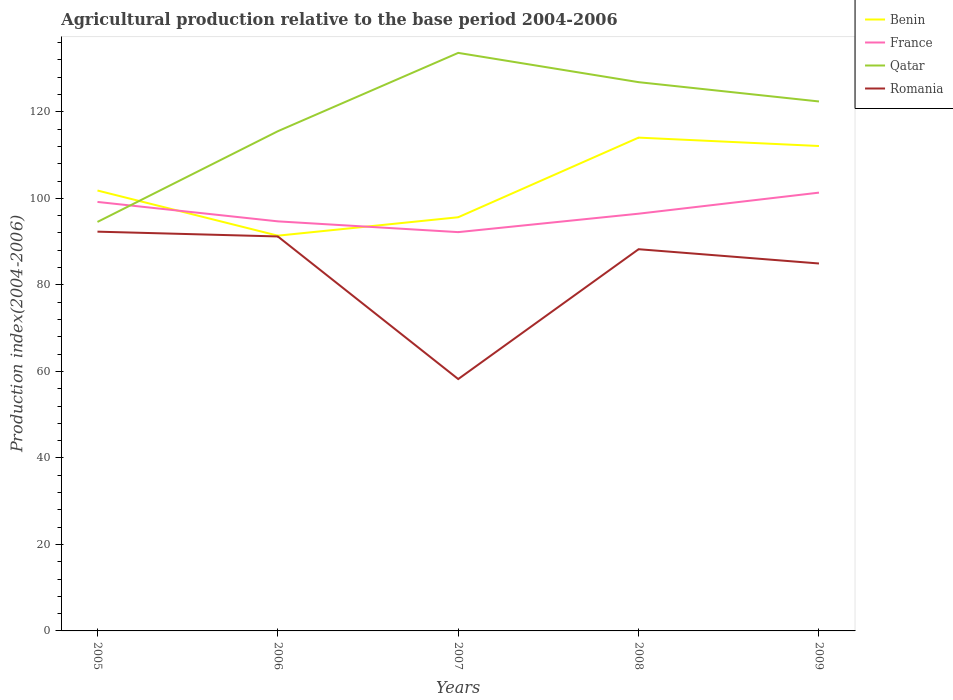Does the line corresponding to Qatar intersect with the line corresponding to Romania?
Give a very brief answer. No. Across all years, what is the maximum agricultural production index in Qatar?
Your response must be concise. 94.56. In which year was the agricultural production index in Qatar maximum?
Provide a succinct answer. 2005. What is the total agricultural production index in Romania in the graph?
Ensure brevity in your answer.  7.36. What is the difference between the highest and the second highest agricultural production index in Benin?
Provide a succinct answer. 22.67. What is the difference between the highest and the lowest agricultural production index in Qatar?
Ensure brevity in your answer.  3. Is the agricultural production index in France strictly greater than the agricultural production index in Romania over the years?
Ensure brevity in your answer.  No. How many lines are there?
Your answer should be very brief. 4. How many years are there in the graph?
Make the answer very short. 5. Are the values on the major ticks of Y-axis written in scientific E-notation?
Your response must be concise. No. Does the graph contain grids?
Ensure brevity in your answer.  No. How are the legend labels stacked?
Ensure brevity in your answer.  Vertical. What is the title of the graph?
Provide a short and direct response. Agricultural production relative to the base period 2004-2006. Does "United Kingdom" appear as one of the legend labels in the graph?
Provide a short and direct response. No. What is the label or title of the Y-axis?
Ensure brevity in your answer.  Production index(2004-2006). What is the Production index(2004-2006) in Benin in 2005?
Offer a very short reply. 101.82. What is the Production index(2004-2006) in France in 2005?
Offer a terse response. 99.18. What is the Production index(2004-2006) in Qatar in 2005?
Your answer should be compact. 94.56. What is the Production index(2004-2006) of Romania in 2005?
Offer a very short reply. 92.31. What is the Production index(2004-2006) of Benin in 2006?
Make the answer very short. 91.38. What is the Production index(2004-2006) of France in 2006?
Make the answer very short. 94.69. What is the Production index(2004-2006) in Qatar in 2006?
Provide a succinct answer. 115.53. What is the Production index(2004-2006) in Romania in 2006?
Your response must be concise. 91.2. What is the Production index(2004-2006) in Benin in 2007?
Keep it short and to the point. 95.64. What is the Production index(2004-2006) in France in 2007?
Offer a terse response. 92.2. What is the Production index(2004-2006) in Qatar in 2007?
Make the answer very short. 133.64. What is the Production index(2004-2006) in Romania in 2007?
Give a very brief answer. 58.23. What is the Production index(2004-2006) of Benin in 2008?
Keep it short and to the point. 114.05. What is the Production index(2004-2006) of France in 2008?
Keep it short and to the point. 96.46. What is the Production index(2004-2006) in Qatar in 2008?
Your response must be concise. 126.87. What is the Production index(2004-2006) of Romania in 2008?
Your answer should be compact. 88.25. What is the Production index(2004-2006) in Benin in 2009?
Make the answer very short. 112.11. What is the Production index(2004-2006) of France in 2009?
Offer a very short reply. 101.33. What is the Production index(2004-2006) of Qatar in 2009?
Your response must be concise. 122.41. What is the Production index(2004-2006) in Romania in 2009?
Your answer should be very brief. 84.95. Across all years, what is the maximum Production index(2004-2006) of Benin?
Make the answer very short. 114.05. Across all years, what is the maximum Production index(2004-2006) in France?
Your answer should be compact. 101.33. Across all years, what is the maximum Production index(2004-2006) in Qatar?
Give a very brief answer. 133.64. Across all years, what is the maximum Production index(2004-2006) in Romania?
Provide a succinct answer. 92.31. Across all years, what is the minimum Production index(2004-2006) in Benin?
Keep it short and to the point. 91.38. Across all years, what is the minimum Production index(2004-2006) of France?
Your answer should be very brief. 92.2. Across all years, what is the minimum Production index(2004-2006) of Qatar?
Keep it short and to the point. 94.56. Across all years, what is the minimum Production index(2004-2006) in Romania?
Provide a succinct answer. 58.23. What is the total Production index(2004-2006) of Benin in the graph?
Ensure brevity in your answer.  515. What is the total Production index(2004-2006) of France in the graph?
Your answer should be very brief. 483.86. What is the total Production index(2004-2006) in Qatar in the graph?
Provide a succinct answer. 593.01. What is the total Production index(2004-2006) in Romania in the graph?
Your answer should be compact. 414.94. What is the difference between the Production index(2004-2006) in Benin in 2005 and that in 2006?
Make the answer very short. 10.44. What is the difference between the Production index(2004-2006) in France in 2005 and that in 2006?
Your answer should be very brief. 4.49. What is the difference between the Production index(2004-2006) in Qatar in 2005 and that in 2006?
Provide a succinct answer. -20.97. What is the difference between the Production index(2004-2006) in Romania in 2005 and that in 2006?
Provide a short and direct response. 1.11. What is the difference between the Production index(2004-2006) in Benin in 2005 and that in 2007?
Ensure brevity in your answer.  6.18. What is the difference between the Production index(2004-2006) of France in 2005 and that in 2007?
Make the answer very short. 6.98. What is the difference between the Production index(2004-2006) of Qatar in 2005 and that in 2007?
Give a very brief answer. -39.08. What is the difference between the Production index(2004-2006) in Romania in 2005 and that in 2007?
Make the answer very short. 34.08. What is the difference between the Production index(2004-2006) of Benin in 2005 and that in 2008?
Offer a very short reply. -12.23. What is the difference between the Production index(2004-2006) of France in 2005 and that in 2008?
Keep it short and to the point. 2.72. What is the difference between the Production index(2004-2006) of Qatar in 2005 and that in 2008?
Ensure brevity in your answer.  -32.31. What is the difference between the Production index(2004-2006) in Romania in 2005 and that in 2008?
Provide a succinct answer. 4.06. What is the difference between the Production index(2004-2006) of Benin in 2005 and that in 2009?
Offer a very short reply. -10.29. What is the difference between the Production index(2004-2006) of France in 2005 and that in 2009?
Provide a short and direct response. -2.15. What is the difference between the Production index(2004-2006) of Qatar in 2005 and that in 2009?
Provide a succinct answer. -27.85. What is the difference between the Production index(2004-2006) of Romania in 2005 and that in 2009?
Provide a short and direct response. 7.36. What is the difference between the Production index(2004-2006) of Benin in 2006 and that in 2007?
Keep it short and to the point. -4.26. What is the difference between the Production index(2004-2006) of France in 2006 and that in 2007?
Make the answer very short. 2.49. What is the difference between the Production index(2004-2006) in Qatar in 2006 and that in 2007?
Provide a short and direct response. -18.11. What is the difference between the Production index(2004-2006) of Romania in 2006 and that in 2007?
Provide a succinct answer. 32.97. What is the difference between the Production index(2004-2006) of Benin in 2006 and that in 2008?
Your answer should be compact. -22.67. What is the difference between the Production index(2004-2006) in France in 2006 and that in 2008?
Provide a short and direct response. -1.77. What is the difference between the Production index(2004-2006) of Qatar in 2006 and that in 2008?
Give a very brief answer. -11.34. What is the difference between the Production index(2004-2006) of Romania in 2006 and that in 2008?
Your answer should be compact. 2.95. What is the difference between the Production index(2004-2006) of Benin in 2006 and that in 2009?
Ensure brevity in your answer.  -20.73. What is the difference between the Production index(2004-2006) in France in 2006 and that in 2009?
Offer a very short reply. -6.64. What is the difference between the Production index(2004-2006) of Qatar in 2006 and that in 2009?
Ensure brevity in your answer.  -6.88. What is the difference between the Production index(2004-2006) of Romania in 2006 and that in 2009?
Keep it short and to the point. 6.25. What is the difference between the Production index(2004-2006) of Benin in 2007 and that in 2008?
Give a very brief answer. -18.41. What is the difference between the Production index(2004-2006) of France in 2007 and that in 2008?
Offer a very short reply. -4.26. What is the difference between the Production index(2004-2006) of Qatar in 2007 and that in 2008?
Keep it short and to the point. 6.77. What is the difference between the Production index(2004-2006) in Romania in 2007 and that in 2008?
Your answer should be very brief. -30.02. What is the difference between the Production index(2004-2006) of Benin in 2007 and that in 2009?
Offer a terse response. -16.47. What is the difference between the Production index(2004-2006) of France in 2007 and that in 2009?
Offer a very short reply. -9.13. What is the difference between the Production index(2004-2006) of Qatar in 2007 and that in 2009?
Ensure brevity in your answer.  11.23. What is the difference between the Production index(2004-2006) in Romania in 2007 and that in 2009?
Ensure brevity in your answer.  -26.72. What is the difference between the Production index(2004-2006) of Benin in 2008 and that in 2009?
Your answer should be compact. 1.94. What is the difference between the Production index(2004-2006) of France in 2008 and that in 2009?
Your answer should be compact. -4.87. What is the difference between the Production index(2004-2006) of Qatar in 2008 and that in 2009?
Offer a terse response. 4.46. What is the difference between the Production index(2004-2006) of Benin in 2005 and the Production index(2004-2006) of France in 2006?
Your answer should be very brief. 7.13. What is the difference between the Production index(2004-2006) in Benin in 2005 and the Production index(2004-2006) in Qatar in 2006?
Give a very brief answer. -13.71. What is the difference between the Production index(2004-2006) in Benin in 2005 and the Production index(2004-2006) in Romania in 2006?
Give a very brief answer. 10.62. What is the difference between the Production index(2004-2006) in France in 2005 and the Production index(2004-2006) in Qatar in 2006?
Ensure brevity in your answer.  -16.35. What is the difference between the Production index(2004-2006) in France in 2005 and the Production index(2004-2006) in Romania in 2006?
Your answer should be very brief. 7.98. What is the difference between the Production index(2004-2006) of Qatar in 2005 and the Production index(2004-2006) of Romania in 2006?
Provide a succinct answer. 3.36. What is the difference between the Production index(2004-2006) of Benin in 2005 and the Production index(2004-2006) of France in 2007?
Make the answer very short. 9.62. What is the difference between the Production index(2004-2006) in Benin in 2005 and the Production index(2004-2006) in Qatar in 2007?
Your answer should be compact. -31.82. What is the difference between the Production index(2004-2006) of Benin in 2005 and the Production index(2004-2006) of Romania in 2007?
Give a very brief answer. 43.59. What is the difference between the Production index(2004-2006) of France in 2005 and the Production index(2004-2006) of Qatar in 2007?
Give a very brief answer. -34.46. What is the difference between the Production index(2004-2006) of France in 2005 and the Production index(2004-2006) of Romania in 2007?
Provide a short and direct response. 40.95. What is the difference between the Production index(2004-2006) in Qatar in 2005 and the Production index(2004-2006) in Romania in 2007?
Your response must be concise. 36.33. What is the difference between the Production index(2004-2006) of Benin in 2005 and the Production index(2004-2006) of France in 2008?
Give a very brief answer. 5.36. What is the difference between the Production index(2004-2006) of Benin in 2005 and the Production index(2004-2006) of Qatar in 2008?
Make the answer very short. -25.05. What is the difference between the Production index(2004-2006) in Benin in 2005 and the Production index(2004-2006) in Romania in 2008?
Make the answer very short. 13.57. What is the difference between the Production index(2004-2006) of France in 2005 and the Production index(2004-2006) of Qatar in 2008?
Give a very brief answer. -27.69. What is the difference between the Production index(2004-2006) of France in 2005 and the Production index(2004-2006) of Romania in 2008?
Keep it short and to the point. 10.93. What is the difference between the Production index(2004-2006) in Qatar in 2005 and the Production index(2004-2006) in Romania in 2008?
Provide a succinct answer. 6.31. What is the difference between the Production index(2004-2006) of Benin in 2005 and the Production index(2004-2006) of France in 2009?
Give a very brief answer. 0.49. What is the difference between the Production index(2004-2006) in Benin in 2005 and the Production index(2004-2006) in Qatar in 2009?
Keep it short and to the point. -20.59. What is the difference between the Production index(2004-2006) of Benin in 2005 and the Production index(2004-2006) of Romania in 2009?
Your answer should be very brief. 16.87. What is the difference between the Production index(2004-2006) of France in 2005 and the Production index(2004-2006) of Qatar in 2009?
Make the answer very short. -23.23. What is the difference between the Production index(2004-2006) in France in 2005 and the Production index(2004-2006) in Romania in 2009?
Your response must be concise. 14.23. What is the difference between the Production index(2004-2006) of Qatar in 2005 and the Production index(2004-2006) of Romania in 2009?
Provide a succinct answer. 9.61. What is the difference between the Production index(2004-2006) in Benin in 2006 and the Production index(2004-2006) in France in 2007?
Your answer should be very brief. -0.82. What is the difference between the Production index(2004-2006) of Benin in 2006 and the Production index(2004-2006) of Qatar in 2007?
Offer a terse response. -42.26. What is the difference between the Production index(2004-2006) in Benin in 2006 and the Production index(2004-2006) in Romania in 2007?
Ensure brevity in your answer.  33.15. What is the difference between the Production index(2004-2006) in France in 2006 and the Production index(2004-2006) in Qatar in 2007?
Offer a very short reply. -38.95. What is the difference between the Production index(2004-2006) of France in 2006 and the Production index(2004-2006) of Romania in 2007?
Provide a succinct answer. 36.46. What is the difference between the Production index(2004-2006) of Qatar in 2006 and the Production index(2004-2006) of Romania in 2007?
Ensure brevity in your answer.  57.3. What is the difference between the Production index(2004-2006) of Benin in 2006 and the Production index(2004-2006) of France in 2008?
Ensure brevity in your answer.  -5.08. What is the difference between the Production index(2004-2006) of Benin in 2006 and the Production index(2004-2006) of Qatar in 2008?
Give a very brief answer. -35.49. What is the difference between the Production index(2004-2006) in Benin in 2006 and the Production index(2004-2006) in Romania in 2008?
Make the answer very short. 3.13. What is the difference between the Production index(2004-2006) of France in 2006 and the Production index(2004-2006) of Qatar in 2008?
Make the answer very short. -32.18. What is the difference between the Production index(2004-2006) in France in 2006 and the Production index(2004-2006) in Romania in 2008?
Your answer should be very brief. 6.44. What is the difference between the Production index(2004-2006) in Qatar in 2006 and the Production index(2004-2006) in Romania in 2008?
Your answer should be very brief. 27.28. What is the difference between the Production index(2004-2006) in Benin in 2006 and the Production index(2004-2006) in France in 2009?
Offer a very short reply. -9.95. What is the difference between the Production index(2004-2006) of Benin in 2006 and the Production index(2004-2006) of Qatar in 2009?
Your answer should be compact. -31.03. What is the difference between the Production index(2004-2006) of Benin in 2006 and the Production index(2004-2006) of Romania in 2009?
Ensure brevity in your answer.  6.43. What is the difference between the Production index(2004-2006) in France in 2006 and the Production index(2004-2006) in Qatar in 2009?
Provide a succinct answer. -27.72. What is the difference between the Production index(2004-2006) of France in 2006 and the Production index(2004-2006) of Romania in 2009?
Your answer should be very brief. 9.74. What is the difference between the Production index(2004-2006) in Qatar in 2006 and the Production index(2004-2006) in Romania in 2009?
Ensure brevity in your answer.  30.58. What is the difference between the Production index(2004-2006) in Benin in 2007 and the Production index(2004-2006) in France in 2008?
Keep it short and to the point. -0.82. What is the difference between the Production index(2004-2006) in Benin in 2007 and the Production index(2004-2006) in Qatar in 2008?
Ensure brevity in your answer.  -31.23. What is the difference between the Production index(2004-2006) of Benin in 2007 and the Production index(2004-2006) of Romania in 2008?
Provide a succinct answer. 7.39. What is the difference between the Production index(2004-2006) of France in 2007 and the Production index(2004-2006) of Qatar in 2008?
Your answer should be compact. -34.67. What is the difference between the Production index(2004-2006) of France in 2007 and the Production index(2004-2006) of Romania in 2008?
Keep it short and to the point. 3.95. What is the difference between the Production index(2004-2006) of Qatar in 2007 and the Production index(2004-2006) of Romania in 2008?
Your response must be concise. 45.39. What is the difference between the Production index(2004-2006) of Benin in 2007 and the Production index(2004-2006) of France in 2009?
Provide a succinct answer. -5.69. What is the difference between the Production index(2004-2006) in Benin in 2007 and the Production index(2004-2006) in Qatar in 2009?
Make the answer very short. -26.77. What is the difference between the Production index(2004-2006) of Benin in 2007 and the Production index(2004-2006) of Romania in 2009?
Your answer should be very brief. 10.69. What is the difference between the Production index(2004-2006) of France in 2007 and the Production index(2004-2006) of Qatar in 2009?
Provide a succinct answer. -30.21. What is the difference between the Production index(2004-2006) of France in 2007 and the Production index(2004-2006) of Romania in 2009?
Offer a terse response. 7.25. What is the difference between the Production index(2004-2006) in Qatar in 2007 and the Production index(2004-2006) in Romania in 2009?
Your answer should be very brief. 48.69. What is the difference between the Production index(2004-2006) in Benin in 2008 and the Production index(2004-2006) in France in 2009?
Offer a very short reply. 12.72. What is the difference between the Production index(2004-2006) of Benin in 2008 and the Production index(2004-2006) of Qatar in 2009?
Your answer should be compact. -8.36. What is the difference between the Production index(2004-2006) in Benin in 2008 and the Production index(2004-2006) in Romania in 2009?
Your response must be concise. 29.1. What is the difference between the Production index(2004-2006) in France in 2008 and the Production index(2004-2006) in Qatar in 2009?
Offer a terse response. -25.95. What is the difference between the Production index(2004-2006) of France in 2008 and the Production index(2004-2006) of Romania in 2009?
Provide a short and direct response. 11.51. What is the difference between the Production index(2004-2006) of Qatar in 2008 and the Production index(2004-2006) of Romania in 2009?
Keep it short and to the point. 41.92. What is the average Production index(2004-2006) of Benin per year?
Your answer should be compact. 103. What is the average Production index(2004-2006) of France per year?
Keep it short and to the point. 96.77. What is the average Production index(2004-2006) of Qatar per year?
Your answer should be very brief. 118.6. What is the average Production index(2004-2006) of Romania per year?
Ensure brevity in your answer.  82.99. In the year 2005, what is the difference between the Production index(2004-2006) of Benin and Production index(2004-2006) of France?
Offer a very short reply. 2.64. In the year 2005, what is the difference between the Production index(2004-2006) in Benin and Production index(2004-2006) in Qatar?
Make the answer very short. 7.26. In the year 2005, what is the difference between the Production index(2004-2006) in Benin and Production index(2004-2006) in Romania?
Your answer should be compact. 9.51. In the year 2005, what is the difference between the Production index(2004-2006) of France and Production index(2004-2006) of Qatar?
Provide a short and direct response. 4.62. In the year 2005, what is the difference between the Production index(2004-2006) in France and Production index(2004-2006) in Romania?
Keep it short and to the point. 6.87. In the year 2005, what is the difference between the Production index(2004-2006) in Qatar and Production index(2004-2006) in Romania?
Ensure brevity in your answer.  2.25. In the year 2006, what is the difference between the Production index(2004-2006) in Benin and Production index(2004-2006) in France?
Your response must be concise. -3.31. In the year 2006, what is the difference between the Production index(2004-2006) in Benin and Production index(2004-2006) in Qatar?
Offer a terse response. -24.15. In the year 2006, what is the difference between the Production index(2004-2006) in Benin and Production index(2004-2006) in Romania?
Offer a terse response. 0.18. In the year 2006, what is the difference between the Production index(2004-2006) of France and Production index(2004-2006) of Qatar?
Provide a short and direct response. -20.84. In the year 2006, what is the difference between the Production index(2004-2006) in France and Production index(2004-2006) in Romania?
Your answer should be very brief. 3.49. In the year 2006, what is the difference between the Production index(2004-2006) of Qatar and Production index(2004-2006) of Romania?
Offer a very short reply. 24.33. In the year 2007, what is the difference between the Production index(2004-2006) in Benin and Production index(2004-2006) in France?
Provide a short and direct response. 3.44. In the year 2007, what is the difference between the Production index(2004-2006) in Benin and Production index(2004-2006) in Qatar?
Give a very brief answer. -38. In the year 2007, what is the difference between the Production index(2004-2006) in Benin and Production index(2004-2006) in Romania?
Your response must be concise. 37.41. In the year 2007, what is the difference between the Production index(2004-2006) of France and Production index(2004-2006) of Qatar?
Offer a terse response. -41.44. In the year 2007, what is the difference between the Production index(2004-2006) of France and Production index(2004-2006) of Romania?
Provide a succinct answer. 33.97. In the year 2007, what is the difference between the Production index(2004-2006) of Qatar and Production index(2004-2006) of Romania?
Your answer should be very brief. 75.41. In the year 2008, what is the difference between the Production index(2004-2006) of Benin and Production index(2004-2006) of France?
Keep it short and to the point. 17.59. In the year 2008, what is the difference between the Production index(2004-2006) of Benin and Production index(2004-2006) of Qatar?
Give a very brief answer. -12.82. In the year 2008, what is the difference between the Production index(2004-2006) in Benin and Production index(2004-2006) in Romania?
Your answer should be compact. 25.8. In the year 2008, what is the difference between the Production index(2004-2006) in France and Production index(2004-2006) in Qatar?
Your response must be concise. -30.41. In the year 2008, what is the difference between the Production index(2004-2006) in France and Production index(2004-2006) in Romania?
Your answer should be compact. 8.21. In the year 2008, what is the difference between the Production index(2004-2006) of Qatar and Production index(2004-2006) of Romania?
Ensure brevity in your answer.  38.62. In the year 2009, what is the difference between the Production index(2004-2006) of Benin and Production index(2004-2006) of France?
Provide a succinct answer. 10.78. In the year 2009, what is the difference between the Production index(2004-2006) of Benin and Production index(2004-2006) of Qatar?
Your answer should be compact. -10.3. In the year 2009, what is the difference between the Production index(2004-2006) in Benin and Production index(2004-2006) in Romania?
Provide a short and direct response. 27.16. In the year 2009, what is the difference between the Production index(2004-2006) in France and Production index(2004-2006) in Qatar?
Offer a very short reply. -21.08. In the year 2009, what is the difference between the Production index(2004-2006) in France and Production index(2004-2006) in Romania?
Ensure brevity in your answer.  16.38. In the year 2009, what is the difference between the Production index(2004-2006) in Qatar and Production index(2004-2006) in Romania?
Give a very brief answer. 37.46. What is the ratio of the Production index(2004-2006) in Benin in 2005 to that in 2006?
Offer a very short reply. 1.11. What is the ratio of the Production index(2004-2006) of France in 2005 to that in 2006?
Provide a short and direct response. 1.05. What is the ratio of the Production index(2004-2006) in Qatar in 2005 to that in 2006?
Offer a terse response. 0.82. What is the ratio of the Production index(2004-2006) in Romania in 2005 to that in 2006?
Provide a short and direct response. 1.01. What is the ratio of the Production index(2004-2006) in Benin in 2005 to that in 2007?
Keep it short and to the point. 1.06. What is the ratio of the Production index(2004-2006) in France in 2005 to that in 2007?
Keep it short and to the point. 1.08. What is the ratio of the Production index(2004-2006) of Qatar in 2005 to that in 2007?
Your answer should be compact. 0.71. What is the ratio of the Production index(2004-2006) of Romania in 2005 to that in 2007?
Your answer should be very brief. 1.59. What is the ratio of the Production index(2004-2006) in Benin in 2005 to that in 2008?
Provide a short and direct response. 0.89. What is the ratio of the Production index(2004-2006) in France in 2005 to that in 2008?
Your answer should be compact. 1.03. What is the ratio of the Production index(2004-2006) of Qatar in 2005 to that in 2008?
Offer a terse response. 0.75. What is the ratio of the Production index(2004-2006) in Romania in 2005 to that in 2008?
Provide a short and direct response. 1.05. What is the ratio of the Production index(2004-2006) in Benin in 2005 to that in 2009?
Provide a succinct answer. 0.91. What is the ratio of the Production index(2004-2006) of France in 2005 to that in 2009?
Your answer should be compact. 0.98. What is the ratio of the Production index(2004-2006) in Qatar in 2005 to that in 2009?
Your response must be concise. 0.77. What is the ratio of the Production index(2004-2006) of Romania in 2005 to that in 2009?
Offer a very short reply. 1.09. What is the ratio of the Production index(2004-2006) in Benin in 2006 to that in 2007?
Provide a succinct answer. 0.96. What is the ratio of the Production index(2004-2006) of France in 2006 to that in 2007?
Ensure brevity in your answer.  1.03. What is the ratio of the Production index(2004-2006) of Qatar in 2006 to that in 2007?
Provide a short and direct response. 0.86. What is the ratio of the Production index(2004-2006) in Romania in 2006 to that in 2007?
Offer a very short reply. 1.57. What is the ratio of the Production index(2004-2006) in Benin in 2006 to that in 2008?
Provide a succinct answer. 0.8. What is the ratio of the Production index(2004-2006) in France in 2006 to that in 2008?
Give a very brief answer. 0.98. What is the ratio of the Production index(2004-2006) of Qatar in 2006 to that in 2008?
Offer a very short reply. 0.91. What is the ratio of the Production index(2004-2006) in Romania in 2006 to that in 2008?
Ensure brevity in your answer.  1.03. What is the ratio of the Production index(2004-2006) in Benin in 2006 to that in 2009?
Your response must be concise. 0.82. What is the ratio of the Production index(2004-2006) in France in 2006 to that in 2009?
Offer a terse response. 0.93. What is the ratio of the Production index(2004-2006) of Qatar in 2006 to that in 2009?
Make the answer very short. 0.94. What is the ratio of the Production index(2004-2006) of Romania in 2006 to that in 2009?
Offer a very short reply. 1.07. What is the ratio of the Production index(2004-2006) in Benin in 2007 to that in 2008?
Provide a succinct answer. 0.84. What is the ratio of the Production index(2004-2006) in France in 2007 to that in 2008?
Give a very brief answer. 0.96. What is the ratio of the Production index(2004-2006) of Qatar in 2007 to that in 2008?
Your answer should be very brief. 1.05. What is the ratio of the Production index(2004-2006) of Romania in 2007 to that in 2008?
Your answer should be very brief. 0.66. What is the ratio of the Production index(2004-2006) in Benin in 2007 to that in 2009?
Provide a succinct answer. 0.85. What is the ratio of the Production index(2004-2006) in France in 2007 to that in 2009?
Make the answer very short. 0.91. What is the ratio of the Production index(2004-2006) in Qatar in 2007 to that in 2009?
Your answer should be very brief. 1.09. What is the ratio of the Production index(2004-2006) of Romania in 2007 to that in 2009?
Your answer should be compact. 0.69. What is the ratio of the Production index(2004-2006) of Benin in 2008 to that in 2009?
Your response must be concise. 1.02. What is the ratio of the Production index(2004-2006) of France in 2008 to that in 2009?
Give a very brief answer. 0.95. What is the ratio of the Production index(2004-2006) of Qatar in 2008 to that in 2009?
Provide a succinct answer. 1.04. What is the ratio of the Production index(2004-2006) of Romania in 2008 to that in 2009?
Provide a short and direct response. 1.04. What is the difference between the highest and the second highest Production index(2004-2006) of Benin?
Your answer should be very brief. 1.94. What is the difference between the highest and the second highest Production index(2004-2006) of France?
Provide a short and direct response. 2.15. What is the difference between the highest and the second highest Production index(2004-2006) of Qatar?
Your response must be concise. 6.77. What is the difference between the highest and the second highest Production index(2004-2006) in Romania?
Your answer should be compact. 1.11. What is the difference between the highest and the lowest Production index(2004-2006) in Benin?
Make the answer very short. 22.67. What is the difference between the highest and the lowest Production index(2004-2006) of France?
Your answer should be very brief. 9.13. What is the difference between the highest and the lowest Production index(2004-2006) of Qatar?
Provide a short and direct response. 39.08. What is the difference between the highest and the lowest Production index(2004-2006) in Romania?
Provide a succinct answer. 34.08. 